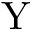<formula> <loc_0><loc_0><loc_500><loc_500>Y</formula> 